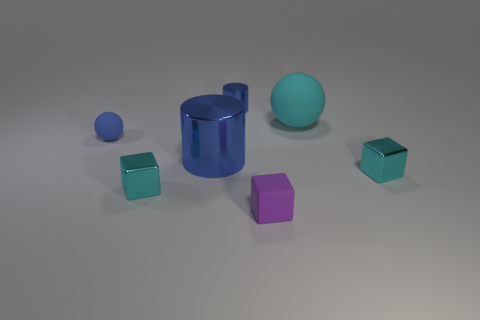Subtract all tiny cyan metallic cubes. How many cubes are left? 1 Add 3 cyan spheres. How many objects exist? 10 Subtract all purple cubes. How many cubes are left? 2 Subtract 2 balls. How many balls are left? 0 Add 2 big blue shiny cubes. How many big blue shiny cubes exist? 2 Subtract 1 cyan cubes. How many objects are left? 6 Subtract all cubes. How many objects are left? 4 Subtract all brown cubes. Subtract all purple balls. How many cubes are left? 3 Subtract all green balls. How many purple blocks are left? 1 Subtract all small purple matte objects. Subtract all yellow cylinders. How many objects are left? 6 